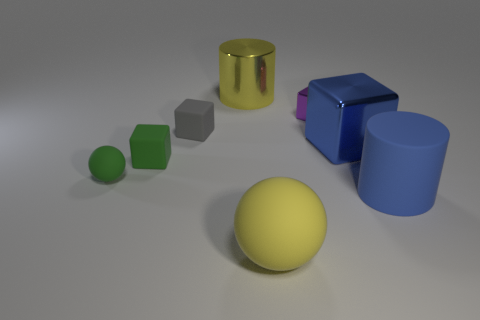How many other objects are the same material as the large blue cylinder?
Your answer should be very brief. 4. Is the shape of the gray thing the same as the yellow thing behind the blue metallic object?
Give a very brief answer. No. What shape is the large yellow object that is made of the same material as the small gray cube?
Your answer should be compact. Sphere. Is the number of small purple objects behind the yellow shiny thing greater than the number of things that are to the right of the matte cylinder?
Your answer should be very brief. No. What number of objects are either big shiny objects or tiny purple matte cubes?
Give a very brief answer. 2. What number of other things are the same color as the big rubber cylinder?
Make the answer very short. 1. What shape is the other shiny thing that is the same size as the yellow shiny thing?
Provide a succinct answer. Cube. There is a big cylinder behind the small gray thing; what color is it?
Offer a terse response. Yellow. How many objects are either green objects behind the green matte ball or small things to the left of the small gray object?
Your answer should be very brief. 2. Do the gray thing and the blue block have the same size?
Give a very brief answer. No. 